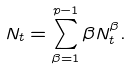Convert formula to latex. <formula><loc_0><loc_0><loc_500><loc_500>N _ { t } = \sum _ { \beta = 1 } ^ { p - 1 } \beta N _ { t } ^ { \beta } .</formula> 